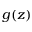<formula> <loc_0><loc_0><loc_500><loc_500>g ( z )</formula> 